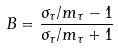<formula> <loc_0><loc_0><loc_500><loc_500>B = \frac { \sigma _ { \tau } / m _ { \tau } - 1 } { \sigma _ { \tau } / m _ { \tau } + 1 }</formula> 